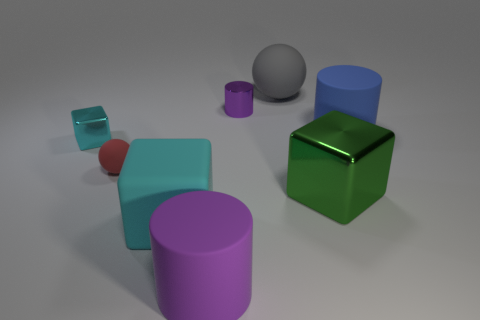Add 1 yellow cylinders. How many objects exist? 9 Subtract all cubes. How many objects are left? 5 Add 8 large cylinders. How many large cylinders exist? 10 Subtract 0 gray cubes. How many objects are left? 8 Subtract all large metal things. Subtract all big rubber blocks. How many objects are left? 6 Add 5 big green shiny cubes. How many big green shiny cubes are left? 6 